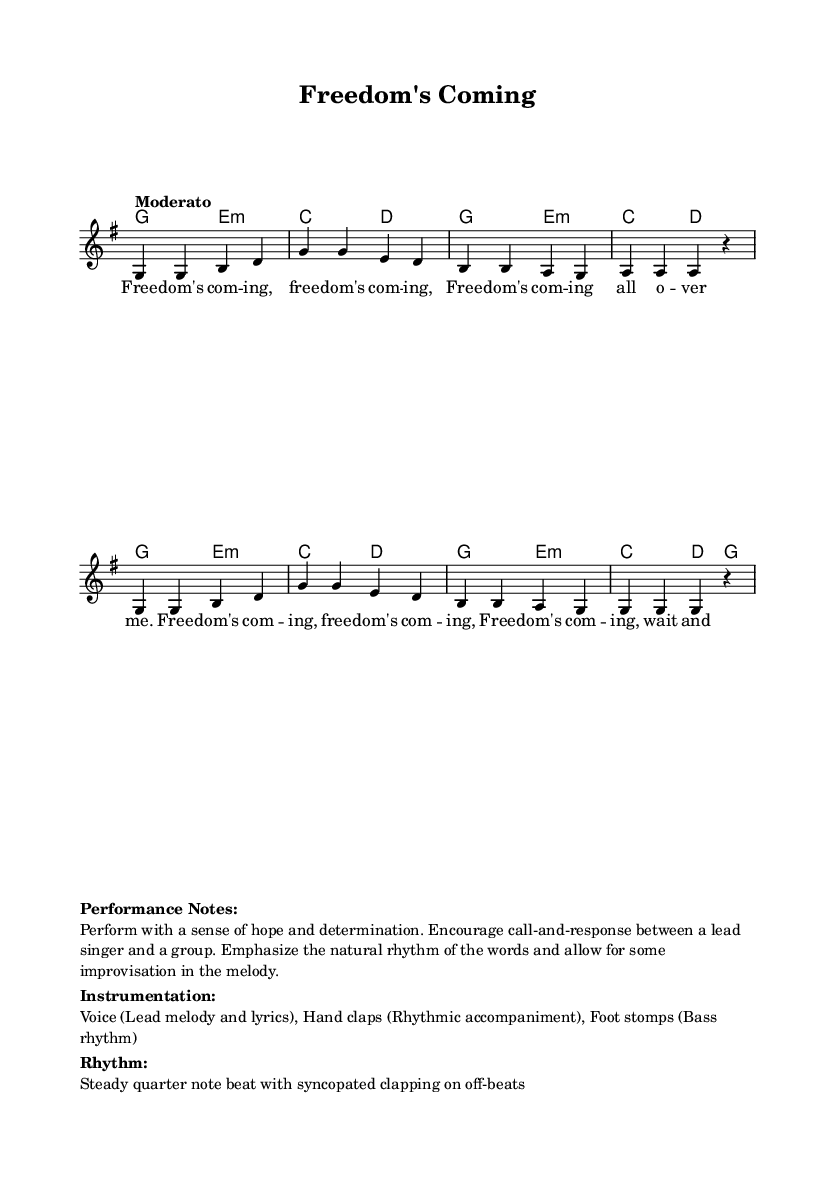What is the key signature of this music? The key signature is G major, which has one sharp (F#). This can be identified by looking at the key signature indication at the beginning of the staff.
Answer: G major What is the time signature of the piece? The time signature is 4/4, which means there are four beats in a measure, and the quarter note gets one beat. This can be seen denoted at the beginning of the score.
Answer: 4/4 What is the tempo marking given in the score? The tempo marking is "Moderato," which indicates a moderate speed for performing the music. This is indicated at the beginning of the score next to the time signature.
Answer: Moderato How many measures are in the melody? The melody consists of eight measures, which can be counted by examining the number of vertical bars separating the phrases.
Answer: 8 What type of musical form is suggested by the repeated lyric "Freedom's Coming"? The repeated lyric suggests a call-and-response form, common in African-American spirituals and work songs, where a leader sings a phrase and the group responds. This is implied through the structure of the lyrics and performance notes.
Answer: Call-and-response What instruments are suggested for performance in the notes? The suggested instruments for performance are voice, hand claps, and foot stomps, as specified in the performance notes below the music. This choice reflects traditional methods of creating rhythm in African-American spirituals.
Answer: Voice, hand claps, foot stomps How should the rhythm be performed according to the notes? The rhythm should be performed as a steady quarter note beat with syncopated clapping on off-beats. This is indicated in the performance notes section, highlighting how the rhythm connects to the spirit of the music.
Answer: Steady quarter note beat with syncopated clapping 